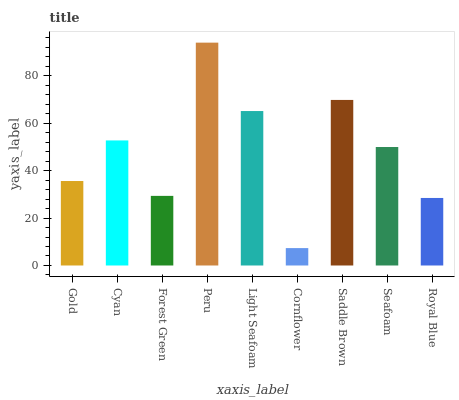Is Cyan the minimum?
Answer yes or no. No. Is Cyan the maximum?
Answer yes or no. No. Is Cyan greater than Gold?
Answer yes or no. Yes. Is Gold less than Cyan?
Answer yes or no. Yes. Is Gold greater than Cyan?
Answer yes or no. No. Is Cyan less than Gold?
Answer yes or no. No. Is Seafoam the high median?
Answer yes or no. Yes. Is Seafoam the low median?
Answer yes or no. Yes. Is Forest Green the high median?
Answer yes or no. No. Is Saddle Brown the low median?
Answer yes or no. No. 